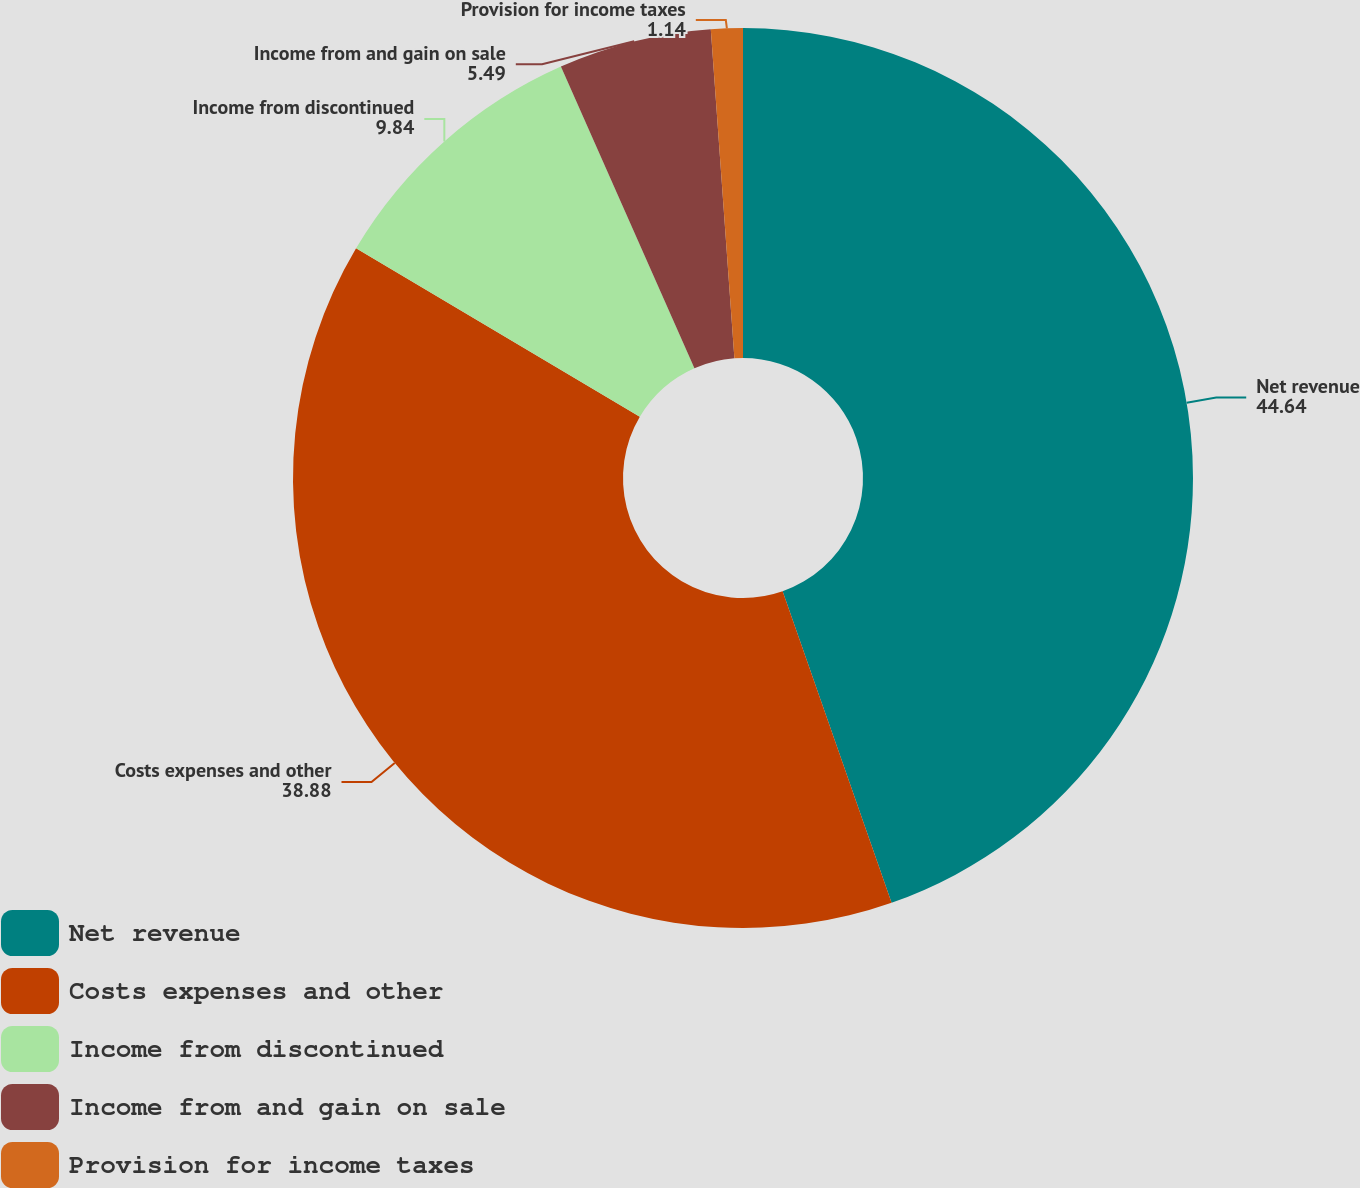Convert chart to OTSL. <chart><loc_0><loc_0><loc_500><loc_500><pie_chart><fcel>Net revenue<fcel>Costs expenses and other<fcel>Income from discontinued<fcel>Income from and gain on sale<fcel>Provision for income taxes<nl><fcel>44.64%<fcel>38.88%<fcel>9.84%<fcel>5.49%<fcel>1.14%<nl></chart> 